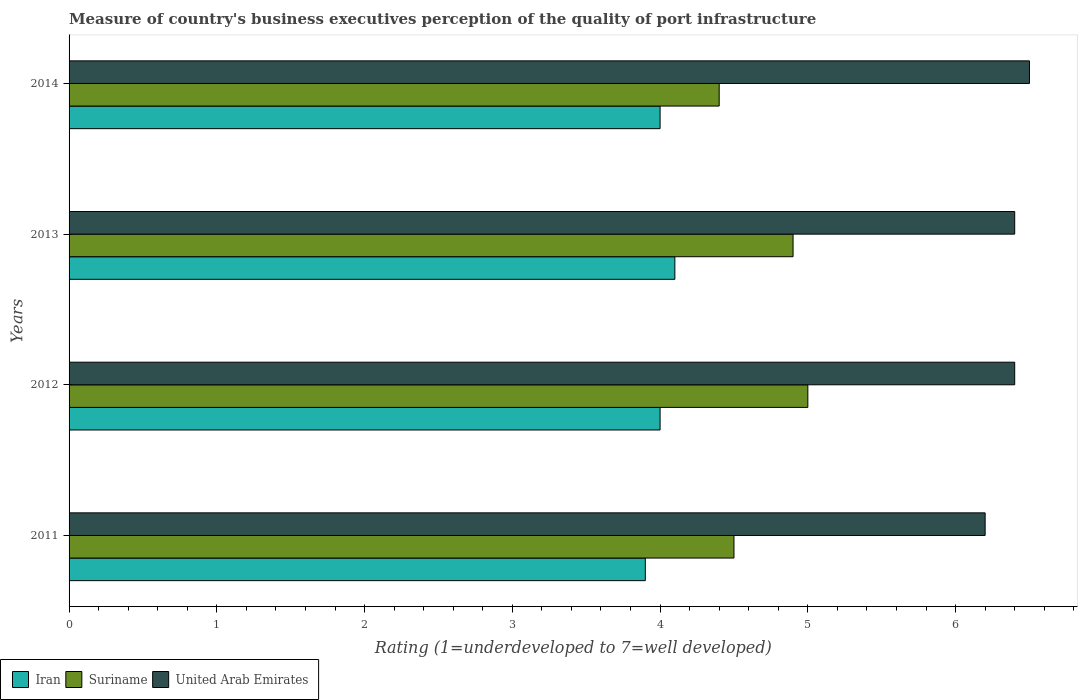How many different coloured bars are there?
Ensure brevity in your answer.  3. How many groups of bars are there?
Your answer should be very brief. 4. Are the number of bars per tick equal to the number of legend labels?
Keep it short and to the point. Yes. How many bars are there on the 4th tick from the top?
Your answer should be compact. 3. What is the label of the 4th group of bars from the top?
Provide a succinct answer. 2011. In how many cases, is the number of bars for a given year not equal to the number of legend labels?
Provide a short and direct response. 0. Across all years, what is the minimum ratings of the quality of port infrastructure in United Arab Emirates?
Offer a very short reply. 6.2. In which year was the ratings of the quality of port infrastructure in United Arab Emirates maximum?
Your answer should be compact. 2014. What is the total ratings of the quality of port infrastructure in United Arab Emirates in the graph?
Offer a terse response. 25.5. What is the difference between the ratings of the quality of port infrastructure in Suriname in 2011 and that in 2014?
Make the answer very short. 0.1. What is the difference between the ratings of the quality of port infrastructure in United Arab Emirates in 2014 and the ratings of the quality of port infrastructure in Suriname in 2013?
Make the answer very short. 1.6. In the year 2013, what is the difference between the ratings of the quality of port infrastructure in Iran and ratings of the quality of port infrastructure in Suriname?
Offer a terse response. -0.8. What is the ratio of the ratings of the quality of port infrastructure in Iran in 2011 to that in 2014?
Make the answer very short. 0.97. Is the difference between the ratings of the quality of port infrastructure in Iran in 2011 and 2013 greater than the difference between the ratings of the quality of port infrastructure in Suriname in 2011 and 2013?
Provide a succinct answer. Yes. What is the difference between the highest and the second highest ratings of the quality of port infrastructure in United Arab Emirates?
Your response must be concise. 0.1. What is the difference between the highest and the lowest ratings of the quality of port infrastructure in United Arab Emirates?
Offer a very short reply. 0.3. Is the sum of the ratings of the quality of port infrastructure in Iran in 2011 and 2012 greater than the maximum ratings of the quality of port infrastructure in Suriname across all years?
Give a very brief answer. Yes. What does the 2nd bar from the top in 2012 represents?
Offer a very short reply. Suriname. What does the 3rd bar from the bottom in 2011 represents?
Offer a terse response. United Arab Emirates. Are all the bars in the graph horizontal?
Offer a very short reply. Yes. What is the difference between two consecutive major ticks on the X-axis?
Provide a short and direct response. 1. Are the values on the major ticks of X-axis written in scientific E-notation?
Offer a very short reply. No. Does the graph contain grids?
Make the answer very short. No. Where does the legend appear in the graph?
Ensure brevity in your answer.  Bottom left. How are the legend labels stacked?
Your answer should be very brief. Horizontal. What is the title of the graph?
Your answer should be very brief. Measure of country's business executives perception of the quality of port infrastructure. What is the label or title of the X-axis?
Offer a very short reply. Rating (1=underdeveloped to 7=well developed). What is the Rating (1=underdeveloped to 7=well developed) of United Arab Emirates in 2011?
Make the answer very short. 6.2. What is the Rating (1=underdeveloped to 7=well developed) of United Arab Emirates in 2012?
Keep it short and to the point. 6.4. What is the Rating (1=underdeveloped to 7=well developed) of Iran in 2013?
Provide a succinct answer. 4.1. What is the Rating (1=underdeveloped to 7=well developed) of Suriname in 2013?
Keep it short and to the point. 4.9. What is the Rating (1=underdeveloped to 7=well developed) of United Arab Emirates in 2014?
Your answer should be compact. 6.5. Across all years, what is the maximum Rating (1=underdeveloped to 7=well developed) of United Arab Emirates?
Provide a succinct answer. 6.5. Across all years, what is the minimum Rating (1=underdeveloped to 7=well developed) of United Arab Emirates?
Ensure brevity in your answer.  6.2. What is the total Rating (1=underdeveloped to 7=well developed) in Iran in the graph?
Your response must be concise. 16. What is the total Rating (1=underdeveloped to 7=well developed) in Suriname in the graph?
Provide a succinct answer. 18.8. What is the difference between the Rating (1=underdeveloped to 7=well developed) of Iran in 2011 and that in 2012?
Offer a terse response. -0.1. What is the difference between the Rating (1=underdeveloped to 7=well developed) in Suriname in 2011 and that in 2012?
Offer a terse response. -0.5. What is the difference between the Rating (1=underdeveloped to 7=well developed) in United Arab Emirates in 2011 and that in 2012?
Provide a succinct answer. -0.2. What is the difference between the Rating (1=underdeveloped to 7=well developed) in Iran in 2011 and that in 2013?
Provide a succinct answer. -0.2. What is the difference between the Rating (1=underdeveloped to 7=well developed) in Iran in 2011 and that in 2014?
Offer a very short reply. -0.1. What is the difference between the Rating (1=underdeveloped to 7=well developed) of United Arab Emirates in 2012 and that in 2013?
Provide a succinct answer. 0. What is the difference between the Rating (1=underdeveloped to 7=well developed) of United Arab Emirates in 2012 and that in 2014?
Give a very brief answer. -0.1. What is the difference between the Rating (1=underdeveloped to 7=well developed) of Iran in 2011 and the Rating (1=underdeveloped to 7=well developed) of Suriname in 2013?
Offer a very short reply. -1. What is the difference between the Rating (1=underdeveloped to 7=well developed) of Suriname in 2011 and the Rating (1=underdeveloped to 7=well developed) of United Arab Emirates in 2013?
Ensure brevity in your answer.  -1.9. What is the difference between the Rating (1=underdeveloped to 7=well developed) in Iran in 2011 and the Rating (1=underdeveloped to 7=well developed) in Suriname in 2014?
Provide a short and direct response. -0.5. What is the difference between the Rating (1=underdeveloped to 7=well developed) of Iran in 2011 and the Rating (1=underdeveloped to 7=well developed) of United Arab Emirates in 2014?
Offer a very short reply. -2.6. What is the difference between the Rating (1=underdeveloped to 7=well developed) of Iran in 2012 and the Rating (1=underdeveloped to 7=well developed) of United Arab Emirates in 2013?
Provide a succinct answer. -2.4. What is the difference between the Rating (1=underdeveloped to 7=well developed) of Suriname in 2012 and the Rating (1=underdeveloped to 7=well developed) of United Arab Emirates in 2013?
Provide a succinct answer. -1.4. What is the difference between the Rating (1=underdeveloped to 7=well developed) in Iran in 2012 and the Rating (1=underdeveloped to 7=well developed) in Suriname in 2014?
Your answer should be compact. -0.4. What is the difference between the Rating (1=underdeveloped to 7=well developed) of Suriname in 2012 and the Rating (1=underdeveloped to 7=well developed) of United Arab Emirates in 2014?
Offer a terse response. -1.5. What is the difference between the Rating (1=underdeveloped to 7=well developed) in Iran in 2013 and the Rating (1=underdeveloped to 7=well developed) in United Arab Emirates in 2014?
Provide a succinct answer. -2.4. What is the average Rating (1=underdeveloped to 7=well developed) of Iran per year?
Offer a very short reply. 4. What is the average Rating (1=underdeveloped to 7=well developed) in Suriname per year?
Make the answer very short. 4.7. What is the average Rating (1=underdeveloped to 7=well developed) in United Arab Emirates per year?
Your answer should be compact. 6.38. In the year 2011, what is the difference between the Rating (1=underdeveloped to 7=well developed) in Iran and Rating (1=underdeveloped to 7=well developed) in United Arab Emirates?
Offer a very short reply. -2.3. In the year 2012, what is the difference between the Rating (1=underdeveloped to 7=well developed) in Iran and Rating (1=underdeveloped to 7=well developed) in Suriname?
Keep it short and to the point. -1. In the year 2012, what is the difference between the Rating (1=underdeveloped to 7=well developed) of Iran and Rating (1=underdeveloped to 7=well developed) of United Arab Emirates?
Offer a very short reply. -2.4. In the year 2013, what is the difference between the Rating (1=underdeveloped to 7=well developed) of Iran and Rating (1=underdeveloped to 7=well developed) of United Arab Emirates?
Offer a terse response. -2.3. In the year 2014, what is the difference between the Rating (1=underdeveloped to 7=well developed) in Iran and Rating (1=underdeveloped to 7=well developed) in Suriname?
Offer a very short reply. -0.4. What is the ratio of the Rating (1=underdeveloped to 7=well developed) of Suriname in 2011 to that in 2012?
Make the answer very short. 0.9. What is the ratio of the Rating (1=underdeveloped to 7=well developed) in United Arab Emirates in 2011 to that in 2012?
Provide a short and direct response. 0.97. What is the ratio of the Rating (1=underdeveloped to 7=well developed) in Iran in 2011 to that in 2013?
Keep it short and to the point. 0.95. What is the ratio of the Rating (1=underdeveloped to 7=well developed) of Suriname in 2011 to that in 2013?
Ensure brevity in your answer.  0.92. What is the ratio of the Rating (1=underdeveloped to 7=well developed) of United Arab Emirates in 2011 to that in 2013?
Make the answer very short. 0.97. What is the ratio of the Rating (1=underdeveloped to 7=well developed) of Suriname in 2011 to that in 2014?
Make the answer very short. 1.02. What is the ratio of the Rating (1=underdeveloped to 7=well developed) of United Arab Emirates in 2011 to that in 2014?
Offer a very short reply. 0.95. What is the ratio of the Rating (1=underdeveloped to 7=well developed) of Iran in 2012 to that in 2013?
Give a very brief answer. 0.98. What is the ratio of the Rating (1=underdeveloped to 7=well developed) of Suriname in 2012 to that in 2013?
Provide a succinct answer. 1.02. What is the ratio of the Rating (1=underdeveloped to 7=well developed) in United Arab Emirates in 2012 to that in 2013?
Make the answer very short. 1. What is the ratio of the Rating (1=underdeveloped to 7=well developed) of Iran in 2012 to that in 2014?
Your answer should be compact. 1. What is the ratio of the Rating (1=underdeveloped to 7=well developed) of Suriname in 2012 to that in 2014?
Keep it short and to the point. 1.14. What is the ratio of the Rating (1=underdeveloped to 7=well developed) in United Arab Emirates in 2012 to that in 2014?
Make the answer very short. 0.98. What is the ratio of the Rating (1=underdeveloped to 7=well developed) of Iran in 2013 to that in 2014?
Give a very brief answer. 1.02. What is the ratio of the Rating (1=underdeveloped to 7=well developed) of Suriname in 2013 to that in 2014?
Make the answer very short. 1.11. What is the ratio of the Rating (1=underdeveloped to 7=well developed) of United Arab Emirates in 2013 to that in 2014?
Provide a short and direct response. 0.98. What is the difference between the highest and the second highest Rating (1=underdeveloped to 7=well developed) of Suriname?
Make the answer very short. 0.1. What is the difference between the highest and the second highest Rating (1=underdeveloped to 7=well developed) of United Arab Emirates?
Your answer should be compact. 0.1. What is the difference between the highest and the lowest Rating (1=underdeveloped to 7=well developed) in Suriname?
Offer a terse response. 0.6. What is the difference between the highest and the lowest Rating (1=underdeveloped to 7=well developed) in United Arab Emirates?
Ensure brevity in your answer.  0.3. 